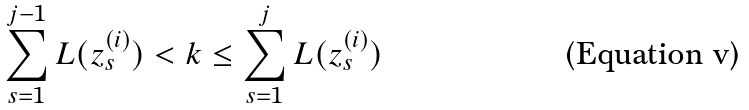Convert formula to latex. <formula><loc_0><loc_0><loc_500><loc_500>\sum _ { s = 1 } ^ { j - 1 } L ( z ^ { ( i ) } _ { s } ) < k \leq \sum _ { s = 1 } ^ { j } L ( z ^ { ( i ) } _ { s } )</formula> 